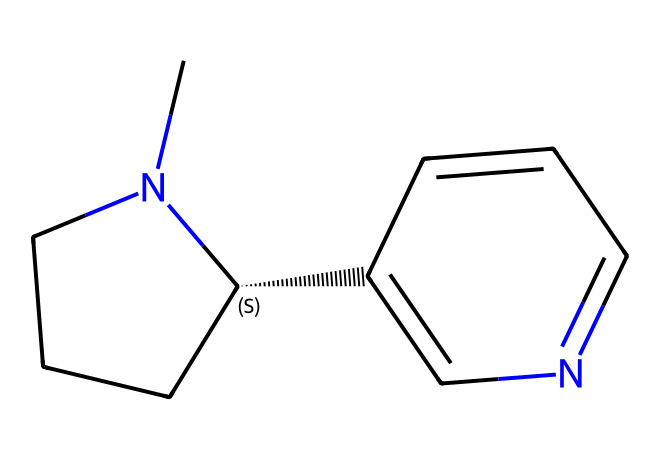How many carbon atoms are in this structure? The SMILES representation indicates the presence of five carbon atoms (C). Each 'C' is counted, and ring formations do not change the total atomic count.
Answer: five What type of chemical is this compound classified as? The presence of a nitrogen atom and the overall structure aligns it with the classification of alkaloids, as they typically contain nitrogen and have biological effects.
Answer: alkaloid What is the total number of rings present in this molecule? The structure contains two distinct rings, identified from the notation in the SMILES representation. Each capital letter represents a ring structure.
Answer: two Does this compound contain any oxygen atoms? By examining the SMILES representation, no oxygen atoms (O) are present as there are only carbon (C) and nitrogen (N) in the structure.
Answer: no What feature of this chemical contributes to its addictive properties? The nitrogen atom plays a significant role in its binding affinity to nicotinic acetylcholine receptors in the brain, which is a key aspect of its addictive nature.
Answer: nitrogen How many double bonds can be found in this molecule? The double bonds can be identified by looking for specific patterns in the SMILES, and there is one double bond present indicated by the presence of '=' in the molecular structure.
Answer: one 